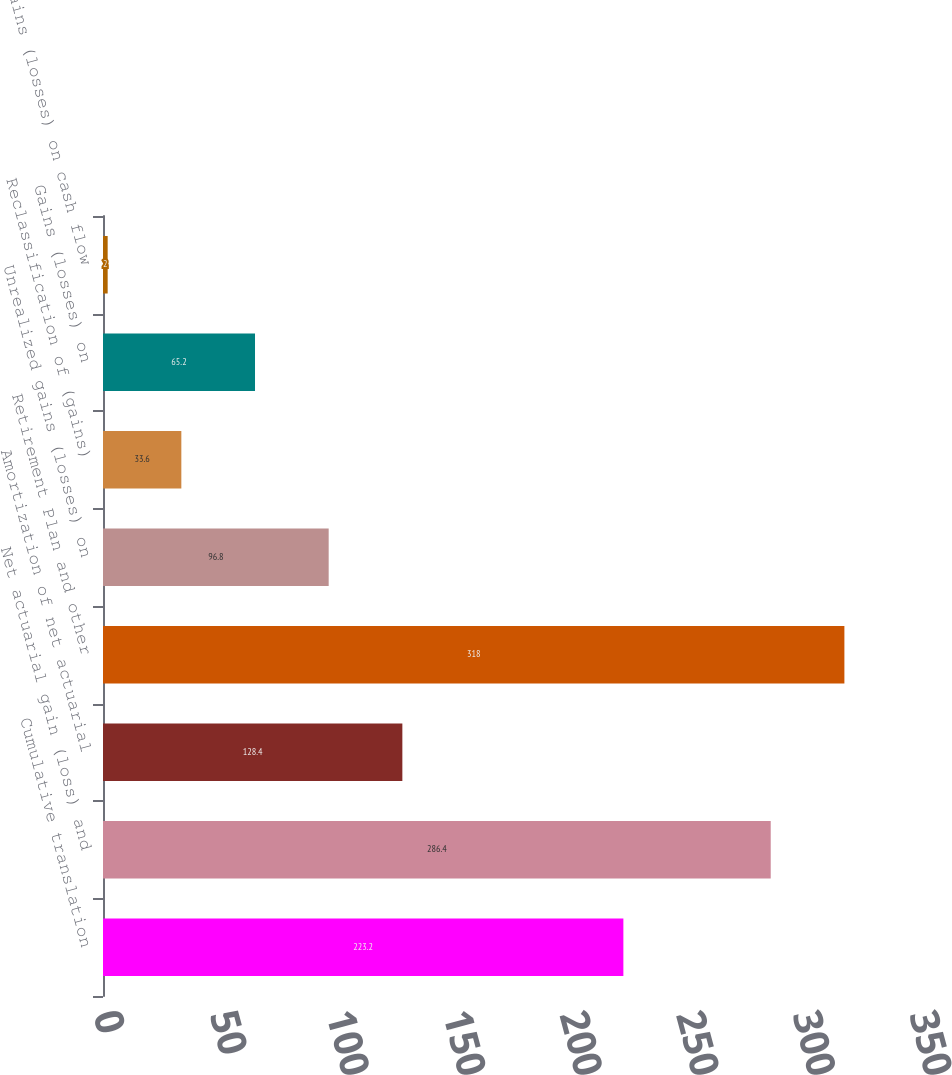<chart> <loc_0><loc_0><loc_500><loc_500><bar_chart><fcel>Cumulative translation<fcel>Net actuarial gain (loss) and<fcel>Amortization of net actuarial<fcel>Retirement Plan and other<fcel>Unrealized gains (losses) on<fcel>Reclassification of (gains)<fcel>Gains (losses) on<fcel>Gains (losses) on cash flow<nl><fcel>223.2<fcel>286.4<fcel>128.4<fcel>318<fcel>96.8<fcel>33.6<fcel>65.2<fcel>2<nl></chart> 